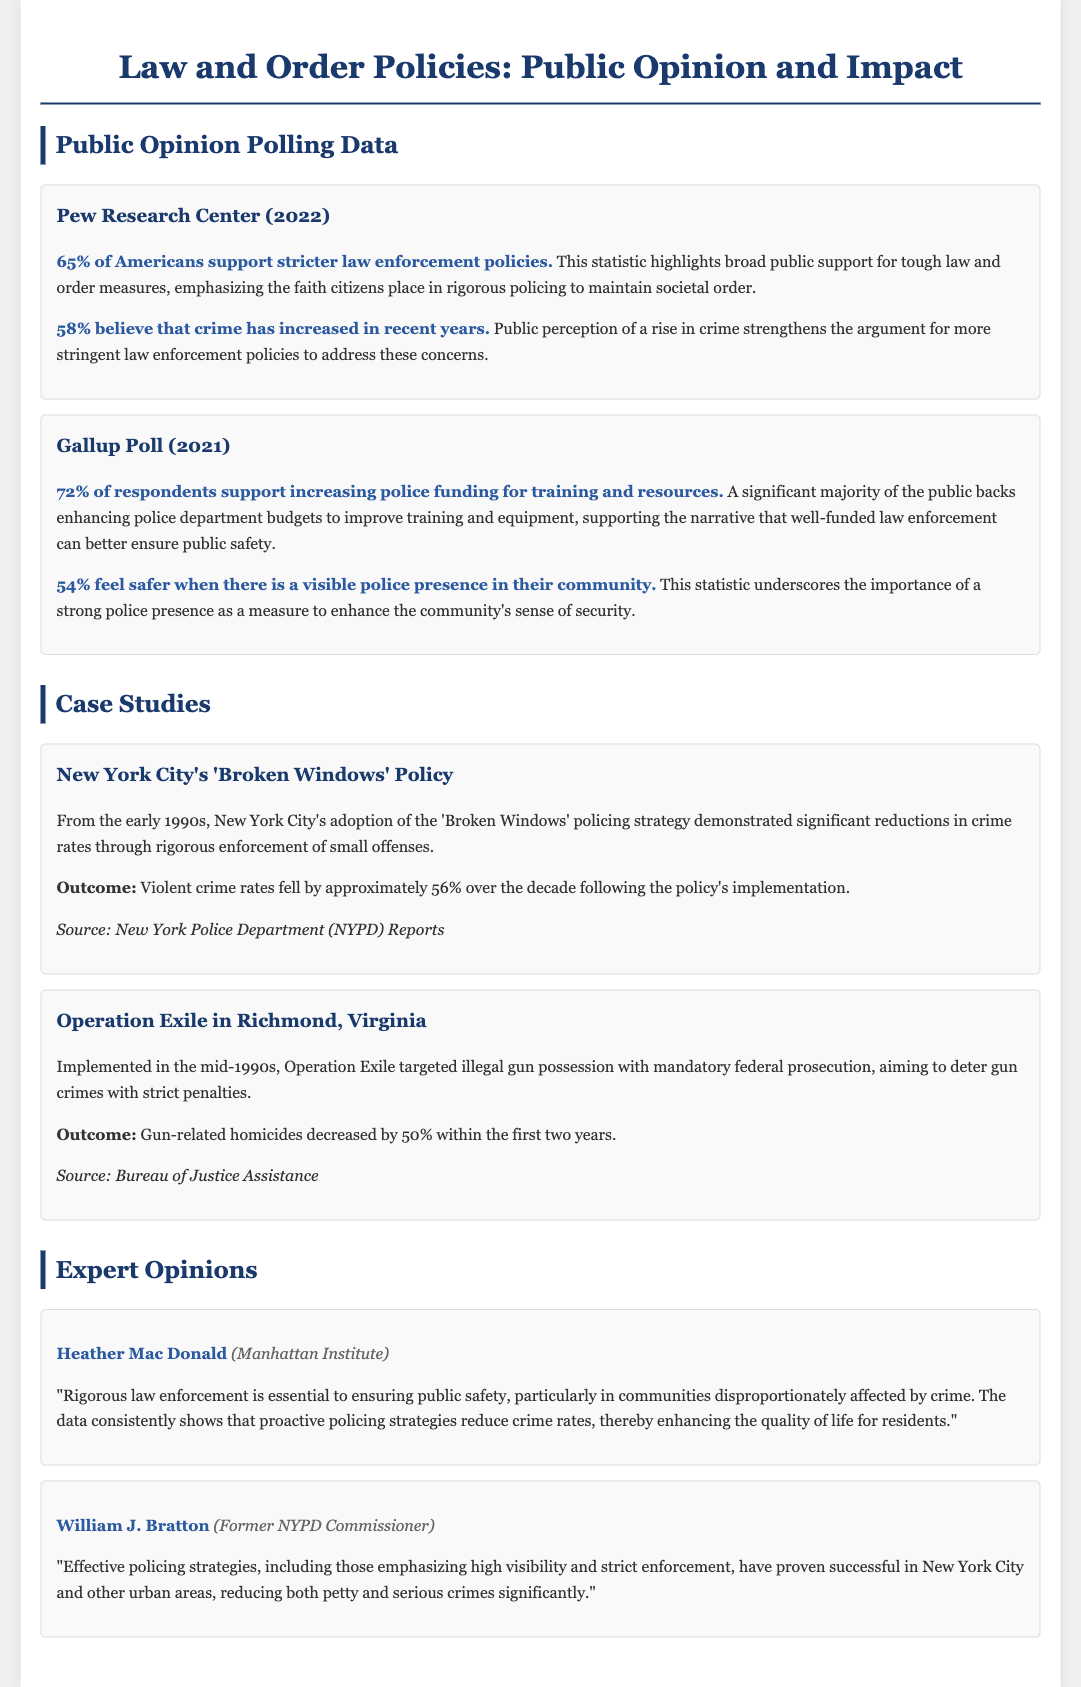What percentage of Americans support stricter law enforcement policies? This percentage is reported in the Pew Research Center poll included in the document.
Answer: 65% What was the outcome of New York City's 'Broken Windows' policy regarding violent crime rates? This outcome is stated clearly in the case study of the policy within the document.
Answer: 56% According to Gallup Poll, what percentage of respondents feel safer with a visible police presence? This percentage can be found in the polling data from Gallup included in the document.
Answer: 54% Who is the expert from the Manhattan Institute that supports rigorous law enforcement? The expert is introduced in the Expert Opinions section of the fact sheet.
Answer: Heather Mac Donald What policy was implemented in Richmond, Virginia, that targeted illegal gun possession? This policy is noted in the case study section of the document.
Answer: Operation Exile What percentage of respondents support increasing police funding for training and resources according to the Gallup Poll? This statistic is detailed in the polling data section of the document.
Answer: 72% What source reports the violent crime rate reduction in New York City's policing strategy? This source is referenced at the end of the relevant case study in the document.
Answer: New York Police Department (NYPD) Reports What significant impact did Operation Exile have on gun-related homicides? This impact is clearly stated in the case study for Operation Exile.
Answer: 50% reduction 